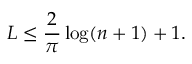Convert formula to latex. <formula><loc_0><loc_0><loc_500><loc_500>L \leq { \frac { 2 } { \pi } } \log ( n + 1 ) + 1 .</formula> 